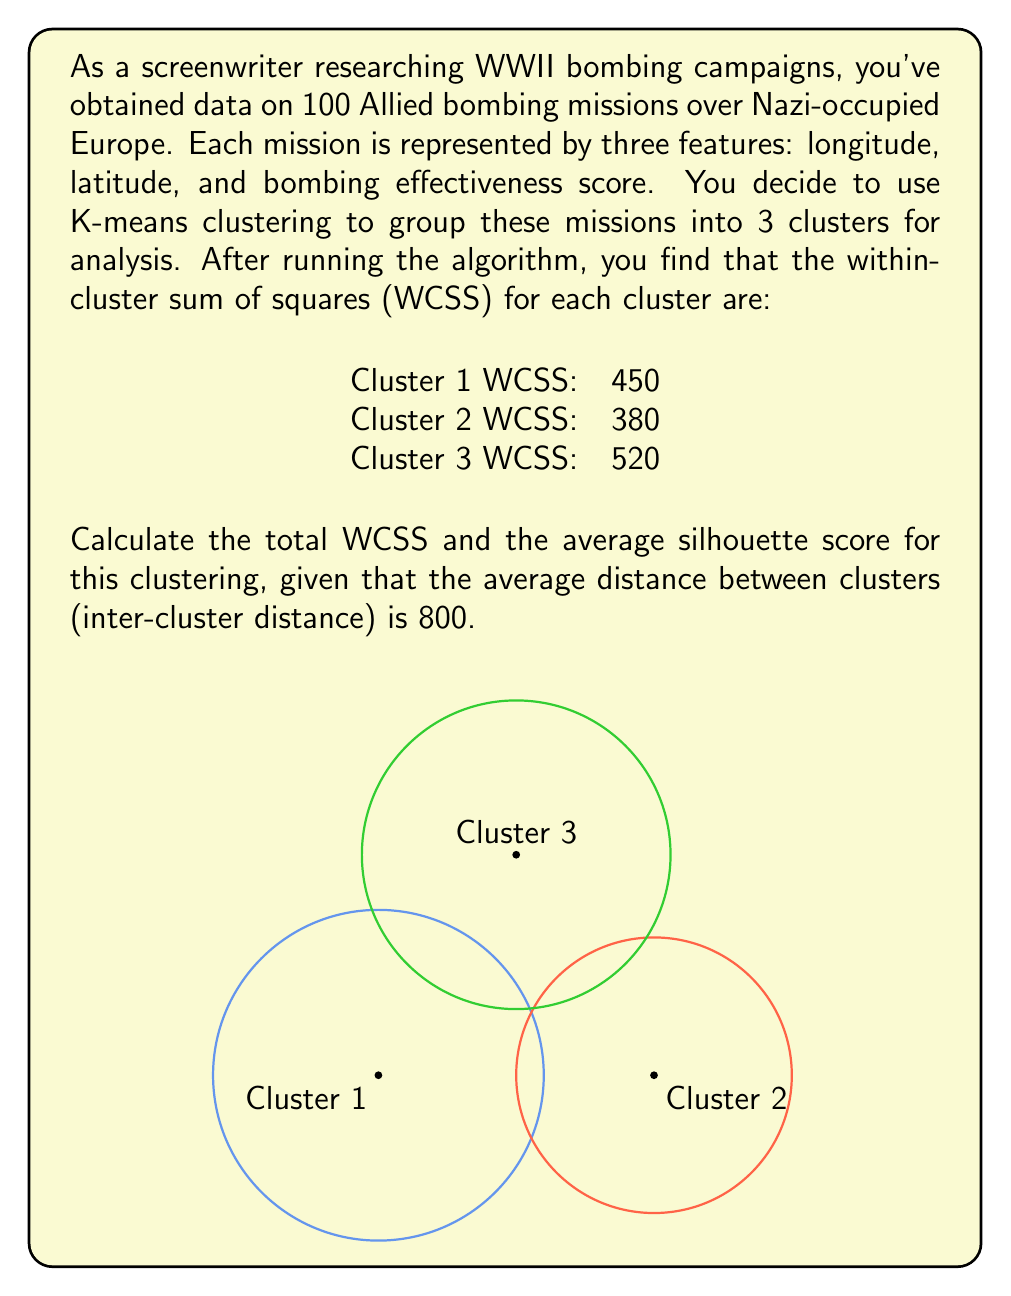What is the answer to this math problem? Let's approach this step-by-step:

1) First, calculate the total WCSS:
   Total WCSS = WCSS1 + WCSS2 + WCSS3
   Total WCSS = 450 + 380 + 520 = 1350

2) The silhouette score measures how similar an object is to its own cluster compared to other clusters. It ranges from -1 to 1, where a high value indicates the object is well matched to its own cluster and poorly matched to neighboring clusters.

3) The average silhouette score (S) is calculated using the formula:
   $$S = \frac{b - a}{\max(a, b)}$$
   where:
   a = average distance of a point to other points in the same cluster (intra-cluster distance)
   b = average distance of a point to points in the nearest neighboring cluster (inter-cluster distance)

4) We're given the inter-cluster distance (b) of 800. We need to calculate the average intra-cluster distance (a).

5) The average intra-cluster distance can be estimated using the average WCSS:
   a ≈ $\sqrt{\frac{\text{Average WCSS}}{\text{Number of features}}}$

6) Average WCSS = Total WCSS / Number of clusters = 1350 / 3 = 450

7) a ≈ $\sqrt{\frac{450}{3}}$ ≈ 12.25

8) Now we can calculate the average silhouette score:
   $$S = \frac{800 - 12.25}{\max(12.25, 800)} = \frac{787.75}{800} ≈ 0.9847$$
Answer: Total WCSS: 1350; Average Silhouette Score: 0.9847 